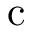<formula> <loc_0><loc_0><loc_500><loc_500>c</formula> 